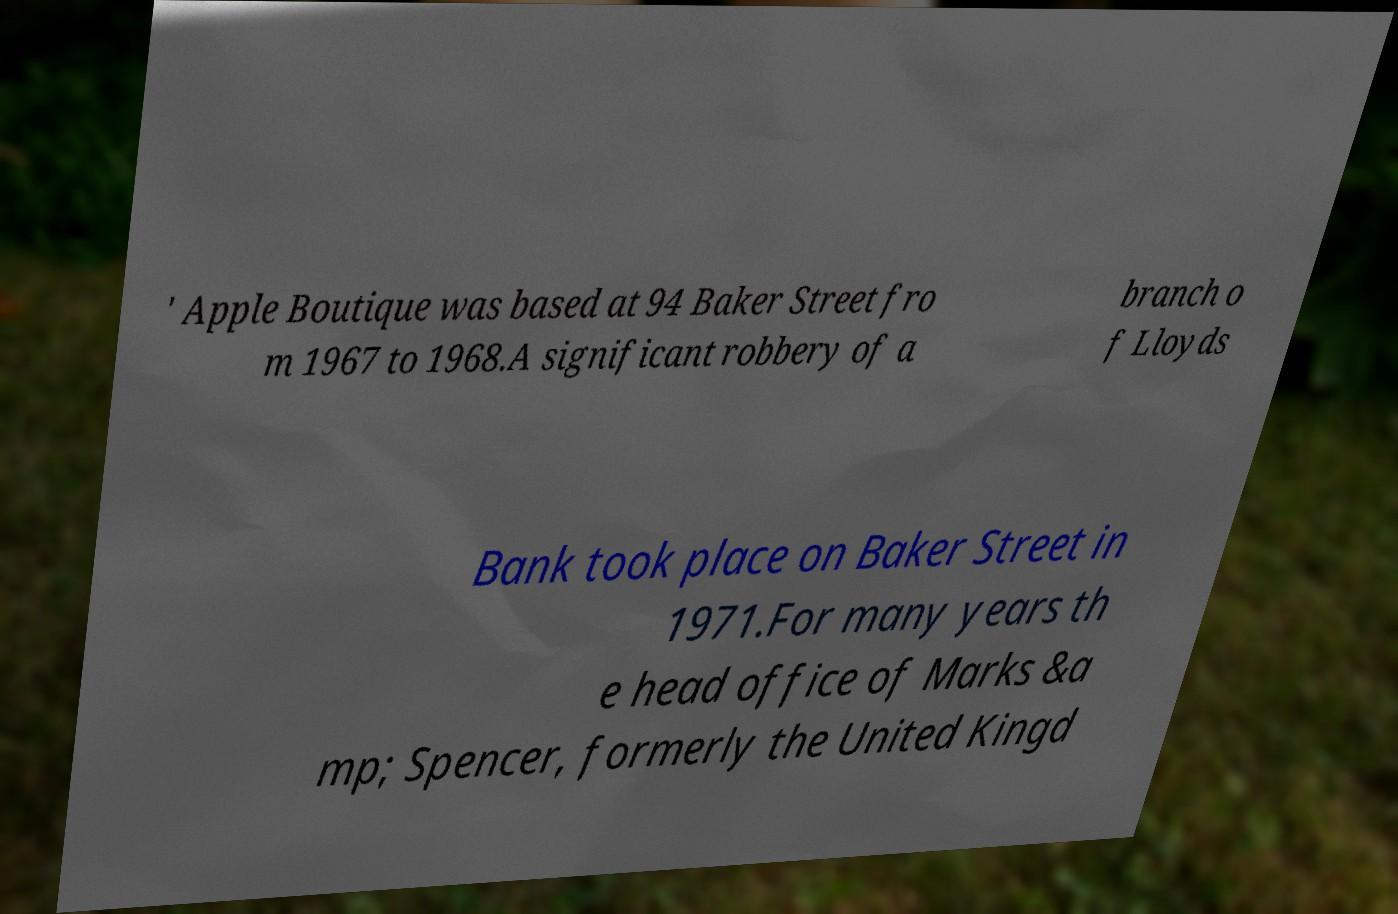I need the written content from this picture converted into text. Can you do that? ' Apple Boutique was based at 94 Baker Street fro m 1967 to 1968.A significant robbery of a branch o f Lloyds Bank took place on Baker Street in 1971.For many years th e head office of Marks &a mp; Spencer, formerly the United Kingd 